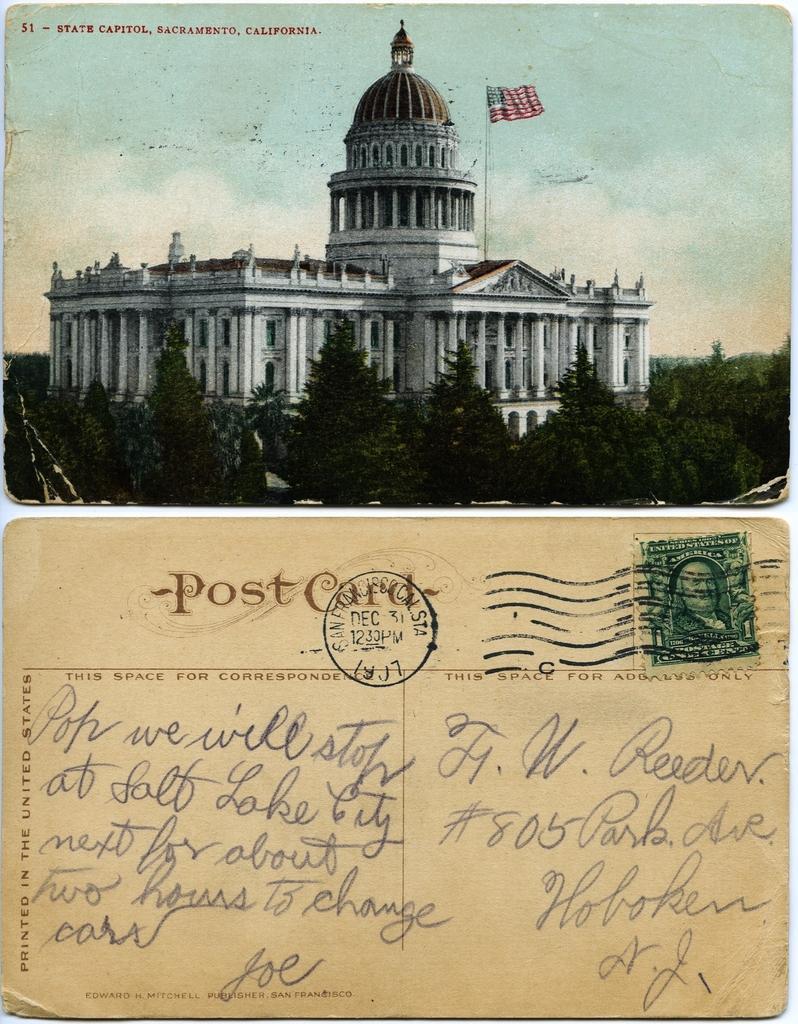Please provide a concise description of this image. This is a collage picture, at the top of the image we can see a building, trees, flag and the sky and at the bottom of the image we can see a postcard without stamp and text on it. 